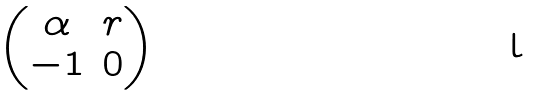Convert formula to latex. <formula><loc_0><loc_0><loc_500><loc_500>\begin{pmatrix} \alpha & r \\ - 1 & 0 \end{pmatrix}</formula> 